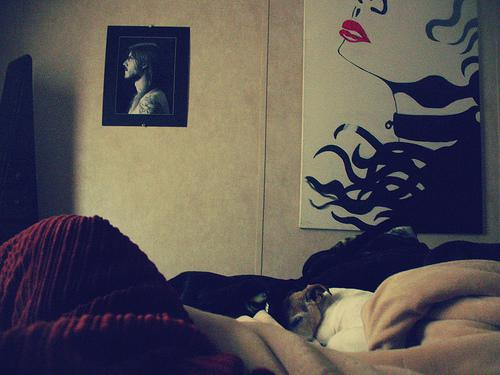Question: what is on top of the dog?
Choices:
A. The boy.
B. The cat.
C. The hat.
D. The blanket.
Answer with the letter. Answer: D Question: who is with the dog?
Choices:
A. The boy.
B. The man.
C. No one.
D. The girl.
Answer with the letter. Answer: C 